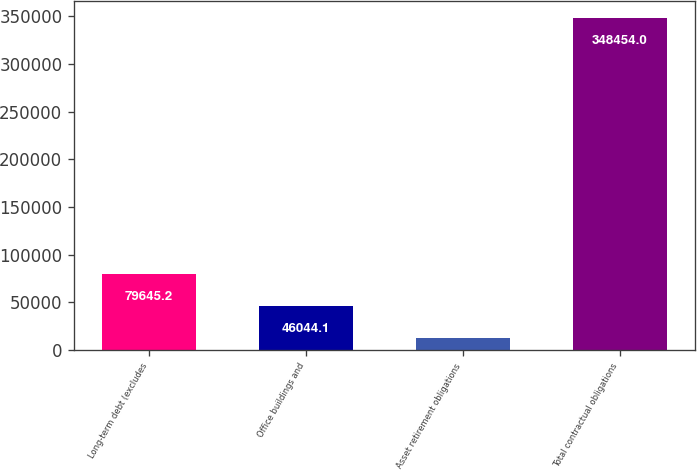<chart> <loc_0><loc_0><loc_500><loc_500><bar_chart><fcel>Long-term debt (excludes<fcel>Office buildings and<fcel>Asset retirement obligations<fcel>Total contractual obligations<nl><fcel>79645.2<fcel>46044.1<fcel>12443<fcel>348454<nl></chart> 